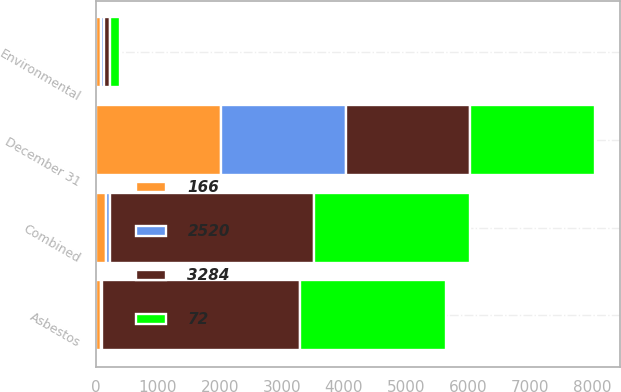Convert chart. <chart><loc_0><loc_0><loc_500><loc_500><stacked_bar_chart><ecel><fcel>December 31<fcel>Asbestos<fcel>Environmental<fcel>Combined<nl><fcel>72<fcel>2014<fcel>2363<fcel>157<fcel>2520<nl><fcel>166<fcel>2014<fcel>79<fcel>87<fcel>166<nl><fcel>3284<fcel>2013<fcel>3190<fcel>94<fcel>3284<nl><fcel>2520<fcel>2013<fcel>16<fcel>51<fcel>67<nl></chart> 